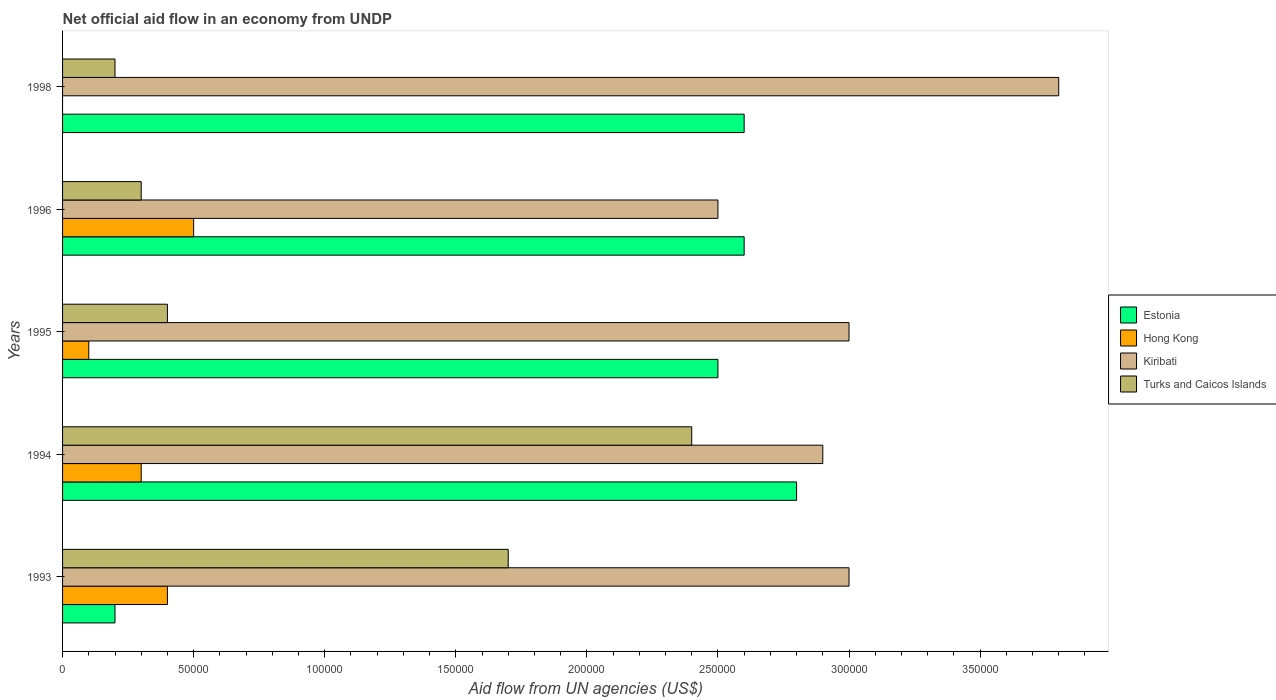How many bars are there on the 5th tick from the top?
Provide a short and direct response. 4. How many bars are there on the 2nd tick from the bottom?
Offer a terse response. 4. What is the net official aid flow in Kiribati in 1993?
Provide a succinct answer. 3.00e+05. What is the total net official aid flow in Estonia in the graph?
Your response must be concise. 1.07e+06. What is the average net official aid flow in Kiribati per year?
Give a very brief answer. 3.04e+05. In the year 1996, what is the difference between the net official aid flow in Kiribati and net official aid flow in Hong Kong?
Make the answer very short. 2.00e+05. In how many years, is the net official aid flow in Hong Kong greater than 320000 US$?
Offer a terse response. 0. What is the ratio of the net official aid flow in Estonia in 1993 to that in 1996?
Your response must be concise. 0.08. Is the difference between the net official aid flow in Kiribati in 1993 and 1996 greater than the difference between the net official aid flow in Hong Kong in 1993 and 1996?
Your answer should be compact. Yes. What is the difference between the highest and the lowest net official aid flow in Hong Kong?
Your answer should be very brief. 5.00e+04. In how many years, is the net official aid flow in Turks and Caicos Islands greater than the average net official aid flow in Turks and Caicos Islands taken over all years?
Ensure brevity in your answer.  2. Is it the case that in every year, the sum of the net official aid flow in Kiribati and net official aid flow in Turks and Caicos Islands is greater than the sum of net official aid flow in Hong Kong and net official aid flow in Estonia?
Your answer should be compact. Yes. Is it the case that in every year, the sum of the net official aid flow in Kiribati and net official aid flow in Turks and Caicos Islands is greater than the net official aid flow in Estonia?
Your answer should be compact. Yes. How many bars are there?
Provide a short and direct response. 19. How many years are there in the graph?
Give a very brief answer. 5. What is the difference between two consecutive major ticks on the X-axis?
Provide a short and direct response. 5.00e+04. Are the values on the major ticks of X-axis written in scientific E-notation?
Offer a very short reply. No. Does the graph contain any zero values?
Ensure brevity in your answer.  Yes. How many legend labels are there?
Give a very brief answer. 4. What is the title of the graph?
Provide a short and direct response. Net official aid flow in an economy from UNDP. Does "Brazil" appear as one of the legend labels in the graph?
Your response must be concise. No. What is the label or title of the X-axis?
Give a very brief answer. Aid flow from UN agencies (US$). What is the Aid flow from UN agencies (US$) in Kiribati in 1994?
Offer a terse response. 2.90e+05. What is the Aid flow from UN agencies (US$) of Turks and Caicos Islands in 1994?
Ensure brevity in your answer.  2.40e+05. What is the Aid flow from UN agencies (US$) in Estonia in 1998?
Provide a short and direct response. 2.60e+05. What is the Aid flow from UN agencies (US$) of Hong Kong in 1998?
Keep it short and to the point. 0. What is the Aid flow from UN agencies (US$) in Kiribati in 1998?
Keep it short and to the point. 3.80e+05. Across all years, what is the maximum Aid flow from UN agencies (US$) of Hong Kong?
Your answer should be very brief. 5.00e+04. Across all years, what is the minimum Aid flow from UN agencies (US$) in Estonia?
Offer a very short reply. 2.00e+04. Across all years, what is the minimum Aid flow from UN agencies (US$) of Hong Kong?
Your answer should be very brief. 0. What is the total Aid flow from UN agencies (US$) of Estonia in the graph?
Your answer should be compact. 1.07e+06. What is the total Aid flow from UN agencies (US$) of Kiribati in the graph?
Offer a very short reply. 1.52e+06. What is the total Aid flow from UN agencies (US$) of Turks and Caicos Islands in the graph?
Provide a short and direct response. 5.00e+05. What is the difference between the Aid flow from UN agencies (US$) of Estonia in 1993 and that in 1995?
Offer a very short reply. -2.30e+05. What is the difference between the Aid flow from UN agencies (US$) of Hong Kong in 1993 and that in 1995?
Offer a terse response. 3.00e+04. What is the difference between the Aid flow from UN agencies (US$) of Kiribati in 1993 and that in 1995?
Provide a succinct answer. 0. What is the difference between the Aid flow from UN agencies (US$) in Turks and Caicos Islands in 1993 and that in 1995?
Offer a terse response. 1.30e+05. What is the difference between the Aid flow from UN agencies (US$) in Estonia in 1993 and that in 1996?
Your answer should be very brief. -2.40e+05. What is the difference between the Aid flow from UN agencies (US$) in Kiribati in 1993 and that in 1996?
Provide a short and direct response. 5.00e+04. What is the difference between the Aid flow from UN agencies (US$) in Turks and Caicos Islands in 1993 and that in 1996?
Ensure brevity in your answer.  1.40e+05. What is the difference between the Aid flow from UN agencies (US$) of Turks and Caicos Islands in 1993 and that in 1998?
Your response must be concise. 1.50e+05. What is the difference between the Aid flow from UN agencies (US$) in Estonia in 1994 and that in 1995?
Your response must be concise. 3.00e+04. What is the difference between the Aid flow from UN agencies (US$) in Hong Kong in 1994 and that in 1995?
Your response must be concise. 2.00e+04. What is the difference between the Aid flow from UN agencies (US$) of Kiribati in 1994 and that in 1995?
Your answer should be compact. -10000. What is the difference between the Aid flow from UN agencies (US$) in Turks and Caicos Islands in 1994 and that in 1995?
Offer a very short reply. 2.00e+05. What is the difference between the Aid flow from UN agencies (US$) of Estonia in 1994 and that in 1996?
Keep it short and to the point. 2.00e+04. What is the difference between the Aid flow from UN agencies (US$) of Hong Kong in 1994 and that in 1996?
Provide a succinct answer. -2.00e+04. What is the difference between the Aid flow from UN agencies (US$) in Kiribati in 1994 and that in 1996?
Give a very brief answer. 4.00e+04. What is the difference between the Aid flow from UN agencies (US$) of Turks and Caicos Islands in 1994 and that in 1996?
Ensure brevity in your answer.  2.10e+05. What is the difference between the Aid flow from UN agencies (US$) of Estonia in 1994 and that in 1998?
Ensure brevity in your answer.  2.00e+04. What is the difference between the Aid flow from UN agencies (US$) of Estonia in 1995 and that in 1996?
Provide a short and direct response. -10000. What is the difference between the Aid flow from UN agencies (US$) of Hong Kong in 1995 and that in 1996?
Offer a very short reply. -4.00e+04. What is the difference between the Aid flow from UN agencies (US$) in Kiribati in 1995 and that in 1996?
Your response must be concise. 5.00e+04. What is the difference between the Aid flow from UN agencies (US$) of Turks and Caicos Islands in 1995 and that in 1996?
Your response must be concise. 10000. What is the difference between the Aid flow from UN agencies (US$) in Kiribati in 1996 and that in 1998?
Keep it short and to the point. -1.30e+05. What is the difference between the Aid flow from UN agencies (US$) in Estonia in 1993 and the Aid flow from UN agencies (US$) in Hong Kong in 1994?
Your answer should be compact. -10000. What is the difference between the Aid flow from UN agencies (US$) in Estonia in 1993 and the Aid flow from UN agencies (US$) in Kiribati in 1994?
Provide a short and direct response. -2.70e+05. What is the difference between the Aid flow from UN agencies (US$) of Hong Kong in 1993 and the Aid flow from UN agencies (US$) of Turks and Caicos Islands in 1994?
Your answer should be compact. -2.00e+05. What is the difference between the Aid flow from UN agencies (US$) of Kiribati in 1993 and the Aid flow from UN agencies (US$) of Turks and Caicos Islands in 1994?
Provide a short and direct response. 6.00e+04. What is the difference between the Aid flow from UN agencies (US$) in Estonia in 1993 and the Aid flow from UN agencies (US$) in Kiribati in 1995?
Offer a terse response. -2.80e+05. What is the difference between the Aid flow from UN agencies (US$) in Hong Kong in 1993 and the Aid flow from UN agencies (US$) in Turks and Caicos Islands in 1995?
Provide a short and direct response. 0. What is the difference between the Aid flow from UN agencies (US$) of Estonia in 1993 and the Aid flow from UN agencies (US$) of Hong Kong in 1996?
Offer a very short reply. -3.00e+04. What is the difference between the Aid flow from UN agencies (US$) of Estonia in 1993 and the Aid flow from UN agencies (US$) of Kiribati in 1996?
Provide a succinct answer. -2.30e+05. What is the difference between the Aid flow from UN agencies (US$) of Estonia in 1993 and the Aid flow from UN agencies (US$) of Turks and Caicos Islands in 1996?
Provide a short and direct response. -10000. What is the difference between the Aid flow from UN agencies (US$) of Hong Kong in 1993 and the Aid flow from UN agencies (US$) of Kiribati in 1996?
Give a very brief answer. -2.10e+05. What is the difference between the Aid flow from UN agencies (US$) of Kiribati in 1993 and the Aid flow from UN agencies (US$) of Turks and Caicos Islands in 1996?
Your answer should be compact. 2.70e+05. What is the difference between the Aid flow from UN agencies (US$) of Estonia in 1993 and the Aid flow from UN agencies (US$) of Kiribati in 1998?
Give a very brief answer. -3.60e+05. What is the difference between the Aid flow from UN agencies (US$) of Kiribati in 1993 and the Aid flow from UN agencies (US$) of Turks and Caicos Islands in 1998?
Your response must be concise. 2.80e+05. What is the difference between the Aid flow from UN agencies (US$) in Estonia in 1994 and the Aid flow from UN agencies (US$) in Kiribati in 1995?
Your answer should be compact. -2.00e+04. What is the difference between the Aid flow from UN agencies (US$) of Estonia in 1994 and the Aid flow from UN agencies (US$) of Turks and Caicos Islands in 1995?
Provide a short and direct response. 2.40e+05. What is the difference between the Aid flow from UN agencies (US$) in Hong Kong in 1994 and the Aid flow from UN agencies (US$) in Kiribati in 1995?
Give a very brief answer. -2.70e+05. What is the difference between the Aid flow from UN agencies (US$) in Kiribati in 1994 and the Aid flow from UN agencies (US$) in Turks and Caicos Islands in 1995?
Your response must be concise. 2.50e+05. What is the difference between the Aid flow from UN agencies (US$) of Estonia in 1994 and the Aid flow from UN agencies (US$) of Hong Kong in 1996?
Offer a very short reply. 2.30e+05. What is the difference between the Aid flow from UN agencies (US$) of Estonia in 1994 and the Aid flow from UN agencies (US$) of Kiribati in 1996?
Offer a very short reply. 3.00e+04. What is the difference between the Aid flow from UN agencies (US$) in Hong Kong in 1994 and the Aid flow from UN agencies (US$) in Kiribati in 1996?
Keep it short and to the point. -2.20e+05. What is the difference between the Aid flow from UN agencies (US$) in Hong Kong in 1994 and the Aid flow from UN agencies (US$) in Turks and Caicos Islands in 1996?
Make the answer very short. 0. What is the difference between the Aid flow from UN agencies (US$) of Kiribati in 1994 and the Aid flow from UN agencies (US$) of Turks and Caicos Islands in 1996?
Offer a terse response. 2.60e+05. What is the difference between the Aid flow from UN agencies (US$) of Hong Kong in 1994 and the Aid flow from UN agencies (US$) of Kiribati in 1998?
Offer a very short reply. -3.50e+05. What is the difference between the Aid flow from UN agencies (US$) in Estonia in 1995 and the Aid flow from UN agencies (US$) in Kiribati in 1996?
Make the answer very short. 0. What is the difference between the Aid flow from UN agencies (US$) in Estonia in 1995 and the Aid flow from UN agencies (US$) in Turks and Caicos Islands in 1996?
Ensure brevity in your answer.  2.20e+05. What is the difference between the Aid flow from UN agencies (US$) of Hong Kong in 1995 and the Aid flow from UN agencies (US$) of Kiribati in 1996?
Your response must be concise. -2.40e+05. What is the difference between the Aid flow from UN agencies (US$) of Hong Kong in 1995 and the Aid flow from UN agencies (US$) of Turks and Caicos Islands in 1996?
Provide a succinct answer. -2.00e+04. What is the difference between the Aid flow from UN agencies (US$) in Kiribati in 1995 and the Aid flow from UN agencies (US$) in Turks and Caicos Islands in 1996?
Keep it short and to the point. 2.70e+05. What is the difference between the Aid flow from UN agencies (US$) in Estonia in 1995 and the Aid flow from UN agencies (US$) in Kiribati in 1998?
Provide a succinct answer. -1.30e+05. What is the difference between the Aid flow from UN agencies (US$) in Hong Kong in 1995 and the Aid flow from UN agencies (US$) in Kiribati in 1998?
Offer a terse response. -3.70e+05. What is the difference between the Aid flow from UN agencies (US$) of Kiribati in 1995 and the Aid flow from UN agencies (US$) of Turks and Caicos Islands in 1998?
Provide a short and direct response. 2.80e+05. What is the difference between the Aid flow from UN agencies (US$) of Hong Kong in 1996 and the Aid flow from UN agencies (US$) of Kiribati in 1998?
Keep it short and to the point. -3.30e+05. What is the difference between the Aid flow from UN agencies (US$) in Hong Kong in 1996 and the Aid flow from UN agencies (US$) in Turks and Caicos Islands in 1998?
Ensure brevity in your answer.  3.00e+04. What is the difference between the Aid flow from UN agencies (US$) of Kiribati in 1996 and the Aid flow from UN agencies (US$) of Turks and Caicos Islands in 1998?
Offer a very short reply. 2.30e+05. What is the average Aid flow from UN agencies (US$) of Estonia per year?
Provide a succinct answer. 2.14e+05. What is the average Aid flow from UN agencies (US$) of Hong Kong per year?
Your answer should be compact. 2.60e+04. What is the average Aid flow from UN agencies (US$) in Kiribati per year?
Keep it short and to the point. 3.04e+05. In the year 1993, what is the difference between the Aid flow from UN agencies (US$) of Estonia and Aid flow from UN agencies (US$) of Kiribati?
Your answer should be compact. -2.80e+05. In the year 1994, what is the difference between the Aid flow from UN agencies (US$) of Hong Kong and Aid flow from UN agencies (US$) of Turks and Caicos Islands?
Provide a short and direct response. -2.10e+05. In the year 1994, what is the difference between the Aid flow from UN agencies (US$) in Kiribati and Aid flow from UN agencies (US$) in Turks and Caicos Islands?
Provide a succinct answer. 5.00e+04. In the year 1995, what is the difference between the Aid flow from UN agencies (US$) in Estonia and Aid flow from UN agencies (US$) in Hong Kong?
Keep it short and to the point. 2.40e+05. In the year 1995, what is the difference between the Aid flow from UN agencies (US$) in Estonia and Aid flow from UN agencies (US$) in Kiribati?
Offer a terse response. -5.00e+04. In the year 1996, what is the difference between the Aid flow from UN agencies (US$) in Estonia and Aid flow from UN agencies (US$) in Kiribati?
Offer a very short reply. 10000. In the year 1996, what is the difference between the Aid flow from UN agencies (US$) of Hong Kong and Aid flow from UN agencies (US$) of Kiribati?
Offer a very short reply. -2.00e+05. In the year 1998, what is the difference between the Aid flow from UN agencies (US$) of Kiribati and Aid flow from UN agencies (US$) of Turks and Caicos Islands?
Provide a succinct answer. 3.60e+05. What is the ratio of the Aid flow from UN agencies (US$) of Estonia in 1993 to that in 1994?
Make the answer very short. 0.07. What is the ratio of the Aid flow from UN agencies (US$) of Hong Kong in 1993 to that in 1994?
Make the answer very short. 1.33. What is the ratio of the Aid flow from UN agencies (US$) of Kiribati in 1993 to that in 1994?
Provide a short and direct response. 1.03. What is the ratio of the Aid flow from UN agencies (US$) in Turks and Caicos Islands in 1993 to that in 1994?
Your answer should be compact. 0.71. What is the ratio of the Aid flow from UN agencies (US$) of Turks and Caicos Islands in 1993 to that in 1995?
Provide a succinct answer. 4.25. What is the ratio of the Aid flow from UN agencies (US$) of Estonia in 1993 to that in 1996?
Your answer should be very brief. 0.08. What is the ratio of the Aid flow from UN agencies (US$) of Hong Kong in 1993 to that in 1996?
Your answer should be compact. 0.8. What is the ratio of the Aid flow from UN agencies (US$) in Turks and Caicos Islands in 1993 to that in 1996?
Give a very brief answer. 5.67. What is the ratio of the Aid flow from UN agencies (US$) of Estonia in 1993 to that in 1998?
Make the answer very short. 0.08. What is the ratio of the Aid flow from UN agencies (US$) in Kiribati in 1993 to that in 1998?
Ensure brevity in your answer.  0.79. What is the ratio of the Aid flow from UN agencies (US$) of Estonia in 1994 to that in 1995?
Your answer should be compact. 1.12. What is the ratio of the Aid flow from UN agencies (US$) of Hong Kong in 1994 to that in 1995?
Make the answer very short. 3. What is the ratio of the Aid flow from UN agencies (US$) of Kiribati in 1994 to that in 1995?
Offer a terse response. 0.97. What is the ratio of the Aid flow from UN agencies (US$) of Estonia in 1994 to that in 1996?
Provide a succinct answer. 1.08. What is the ratio of the Aid flow from UN agencies (US$) in Hong Kong in 1994 to that in 1996?
Make the answer very short. 0.6. What is the ratio of the Aid flow from UN agencies (US$) in Kiribati in 1994 to that in 1996?
Your response must be concise. 1.16. What is the ratio of the Aid flow from UN agencies (US$) of Estonia in 1994 to that in 1998?
Give a very brief answer. 1.08. What is the ratio of the Aid flow from UN agencies (US$) in Kiribati in 1994 to that in 1998?
Provide a succinct answer. 0.76. What is the ratio of the Aid flow from UN agencies (US$) in Estonia in 1995 to that in 1996?
Keep it short and to the point. 0.96. What is the ratio of the Aid flow from UN agencies (US$) in Hong Kong in 1995 to that in 1996?
Make the answer very short. 0.2. What is the ratio of the Aid flow from UN agencies (US$) in Turks and Caicos Islands in 1995 to that in 1996?
Offer a very short reply. 1.33. What is the ratio of the Aid flow from UN agencies (US$) in Estonia in 1995 to that in 1998?
Provide a short and direct response. 0.96. What is the ratio of the Aid flow from UN agencies (US$) in Kiribati in 1995 to that in 1998?
Make the answer very short. 0.79. What is the ratio of the Aid flow from UN agencies (US$) in Turks and Caicos Islands in 1995 to that in 1998?
Your response must be concise. 2. What is the ratio of the Aid flow from UN agencies (US$) in Estonia in 1996 to that in 1998?
Provide a succinct answer. 1. What is the ratio of the Aid flow from UN agencies (US$) in Kiribati in 1996 to that in 1998?
Your answer should be very brief. 0.66. What is the difference between the highest and the second highest Aid flow from UN agencies (US$) of Hong Kong?
Make the answer very short. 10000. What is the difference between the highest and the second highest Aid flow from UN agencies (US$) of Kiribati?
Keep it short and to the point. 8.00e+04. What is the difference between the highest and the second highest Aid flow from UN agencies (US$) of Turks and Caicos Islands?
Provide a short and direct response. 7.00e+04. What is the difference between the highest and the lowest Aid flow from UN agencies (US$) of Estonia?
Provide a short and direct response. 2.60e+05. What is the difference between the highest and the lowest Aid flow from UN agencies (US$) in Kiribati?
Make the answer very short. 1.30e+05. What is the difference between the highest and the lowest Aid flow from UN agencies (US$) of Turks and Caicos Islands?
Provide a succinct answer. 2.20e+05. 